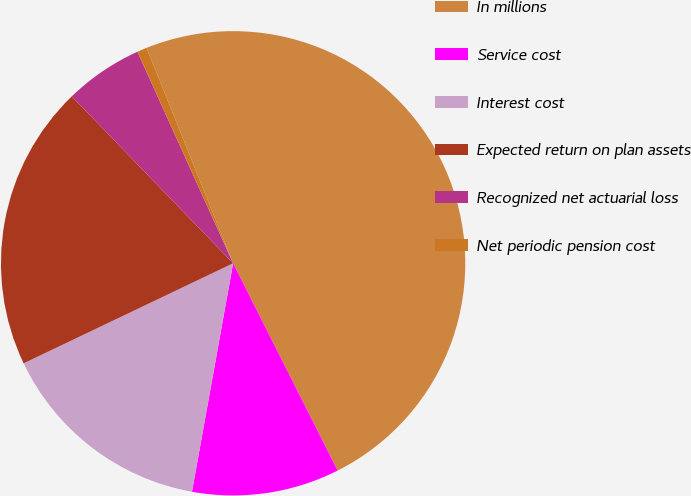Convert chart to OTSL. <chart><loc_0><loc_0><loc_500><loc_500><pie_chart><fcel>In millions<fcel>Service cost<fcel>Interest cost<fcel>Expected return on plan assets<fcel>Recognized net actuarial loss<fcel>Net periodic pension cost<nl><fcel>48.65%<fcel>10.27%<fcel>15.07%<fcel>19.86%<fcel>5.47%<fcel>0.68%<nl></chart> 